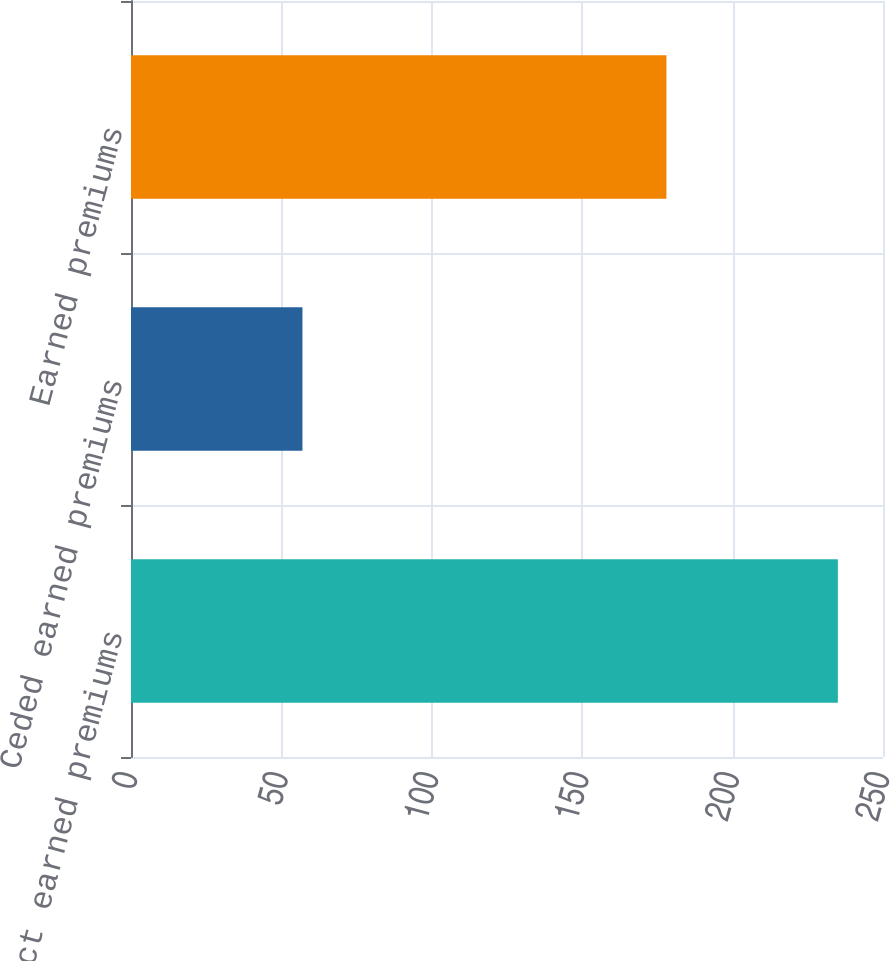<chart> <loc_0><loc_0><loc_500><loc_500><bar_chart><fcel>Direct earned premiums<fcel>Ceded earned premiums<fcel>Earned premiums<nl><fcel>235<fcel>57<fcel>178<nl></chart> 